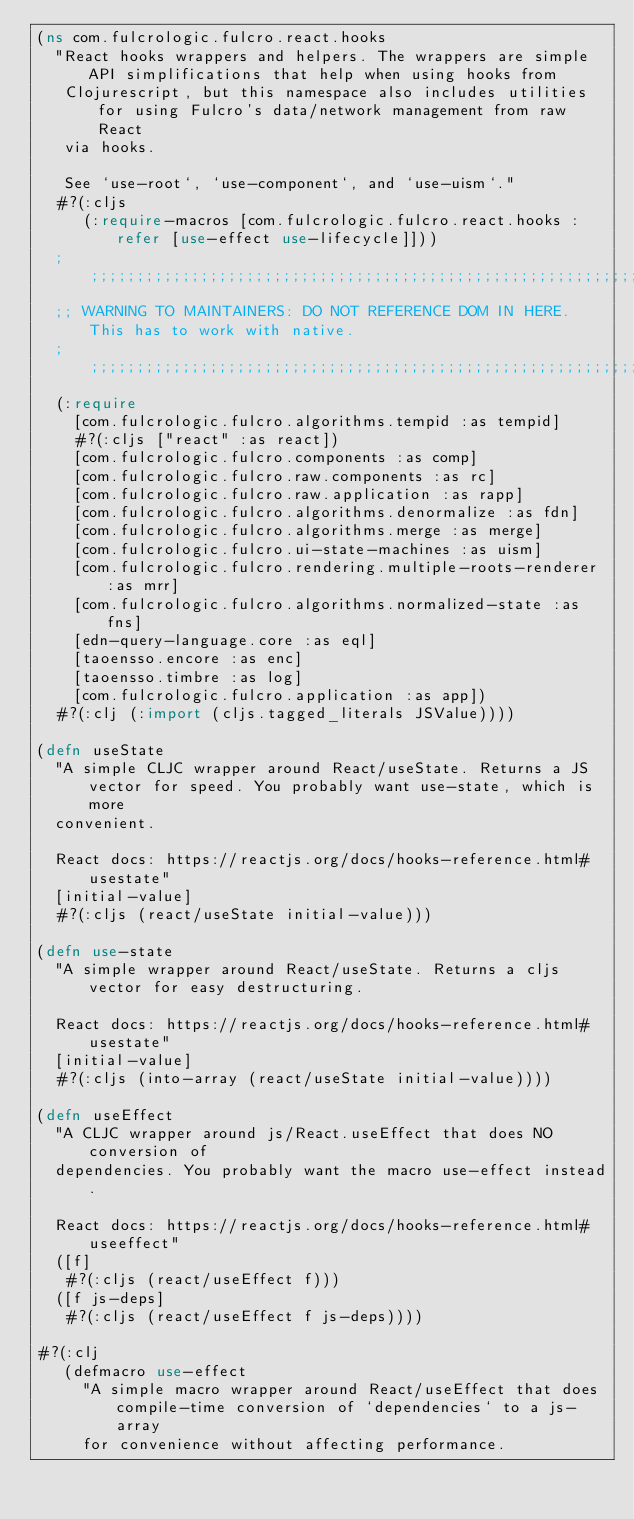Convert code to text. <code><loc_0><loc_0><loc_500><loc_500><_Clojure_>(ns com.fulcrologic.fulcro.react.hooks
  "React hooks wrappers and helpers. The wrappers are simple API simplifications that help when using hooks from
   Clojurescript, but this namespace also includes utilities for using Fulcro's data/network management from raw React
   via hooks.

   See `use-root`, `use-component`, and `use-uism`."
  #?(:cljs
     (:require-macros [com.fulcrologic.fulcro.react.hooks :refer [use-effect use-lifecycle]]))
  ;;;;;;;;;;;;;;;;;;;;;;;;;;;;;;;;;;;;;;;;;;;;;;;;;;;;;;;;;;;;;;;;;;;;;;;;;;;;;;;;
  ;; WARNING TO MAINTAINERS: DO NOT REFERENCE DOM IN HERE. This has to work with native.
  ;;;;;;;;;;;;;;;;;;;;;;;;;;;;;;;;;;;;;;;;;;;;;;;;;;;;;;;;;;;;;;;;;;;;;;;;;;;;;;;;
  (:require
    [com.fulcrologic.fulcro.algorithms.tempid :as tempid]
    #?(:cljs ["react" :as react])
    [com.fulcrologic.fulcro.components :as comp]
    [com.fulcrologic.fulcro.raw.components :as rc]
    [com.fulcrologic.fulcro.raw.application :as rapp]
    [com.fulcrologic.fulcro.algorithms.denormalize :as fdn]
    [com.fulcrologic.fulcro.algorithms.merge :as merge]
    [com.fulcrologic.fulcro.ui-state-machines :as uism]
    [com.fulcrologic.fulcro.rendering.multiple-roots-renderer :as mrr]
    [com.fulcrologic.fulcro.algorithms.normalized-state :as fns]
    [edn-query-language.core :as eql]
    [taoensso.encore :as enc]
    [taoensso.timbre :as log]
    [com.fulcrologic.fulcro.application :as app])
  #?(:clj (:import (cljs.tagged_literals JSValue))))

(defn useState
  "A simple CLJC wrapper around React/useState. Returns a JS vector for speed. You probably want use-state, which is more
  convenient.

  React docs: https://reactjs.org/docs/hooks-reference.html#usestate"
  [initial-value]
  #?(:cljs (react/useState initial-value)))

(defn use-state
  "A simple wrapper around React/useState. Returns a cljs vector for easy destructuring.

  React docs: https://reactjs.org/docs/hooks-reference.html#usestate"
  [initial-value]
  #?(:cljs (into-array (react/useState initial-value))))

(defn useEffect
  "A CLJC wrapper around js/React.useEffect that does NO conversion of
  dependencies. You probably want the macro use-effect instead.

  React docs: https://reactjs.org/docs/hooks-reference.html#useeffect"
  ([f]
   #?(:cljs (react/useEffect f)))
  ([f js-deps]
   #?(:cljs (react/useEffect f js-deps))))

#?(:clj
   (defmacro use-effect
     "A simple macro wrapper around React/useEffect that does compile-time conversion of `dependencies` to a js-array
     for convenience without affecting performance.
</code> 